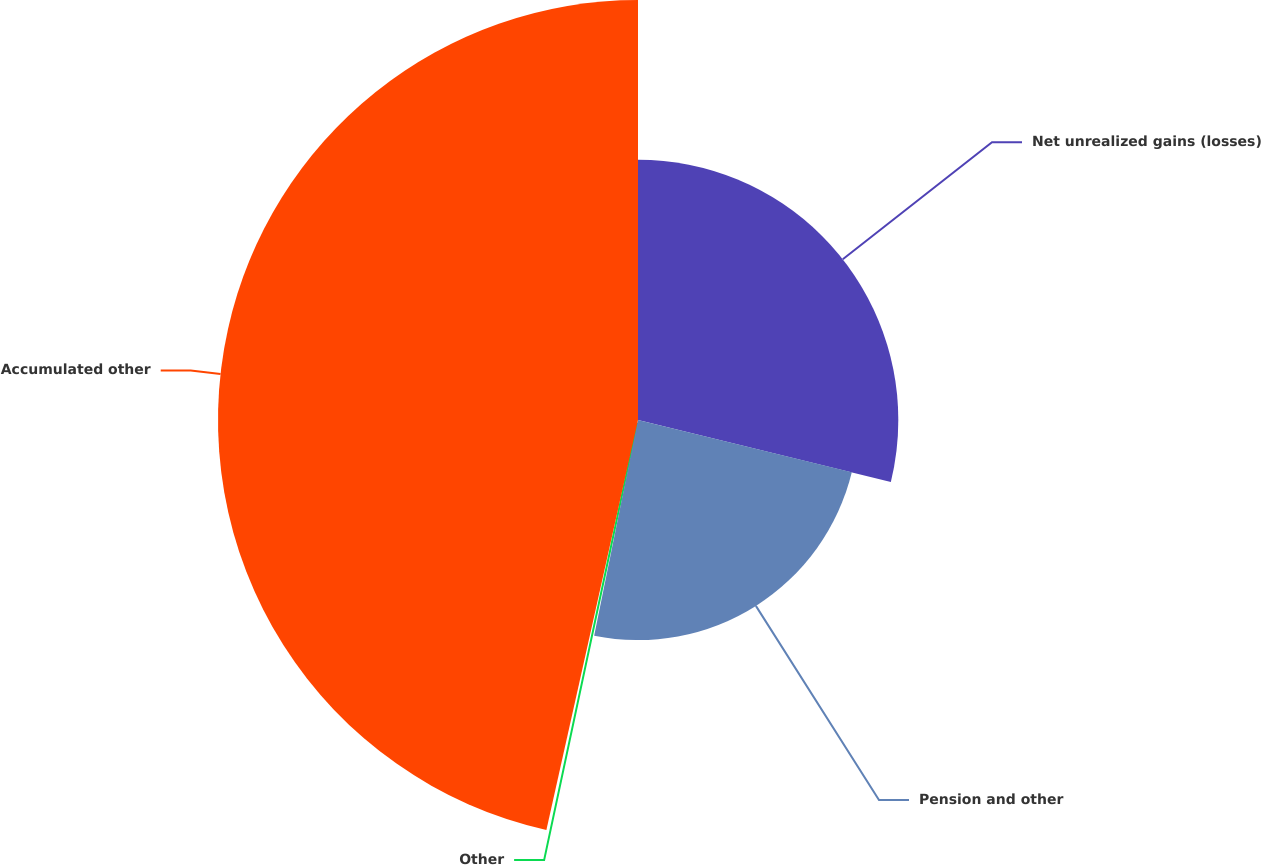Convert chart to OTSL. <chart><loc_0><loc_0><loc_500><loc_500><pie_chart><fcel>Net unrealized gains (losses)<fcel>Pension and other<fcel>Other<fcel>Accumulated other<nl><fcel>28.82%<fcel>24.37%<fcel>0.31%<fcel>46.5%<nl></chart> 